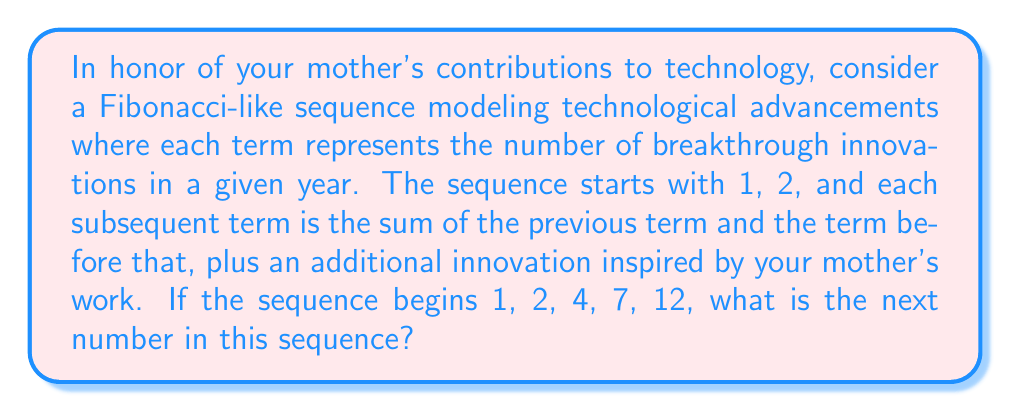Provide a solution to this math problem. Let's approach this step-by-step:

1) First, let's examine the given sequence: 1, 2, 4, 7, 12

2) In a standard Fibonacci sequence, each term is the sum of the two preceding ones. However, this sequence has an additional element.

3) Let's call the additional innovation inspired by your mother's work $m$. We can represent the sequence mathematically as:

   $$a_n = a_{n-1} + a_{n-2} + m$$

4) To find $m$, let's use the given terms:
   
   For $n = 3$: $4 = 2 + 1 + m$, so $m = 1$

5) Let's verify this for the next terms:
   
   For $n = 4$: $7 = 4 + 2 + 1$
   For $n = 5$: $12 = 7 + 4 + 1$

6) Now that we've confirmed the pattern, we can calculate the next term:

   $$a_6 = a_5 + a_4 + m = 12 + 7 + 1 = 20$$

Therefore, the next number in the sequence is 20.
Answer: 20 